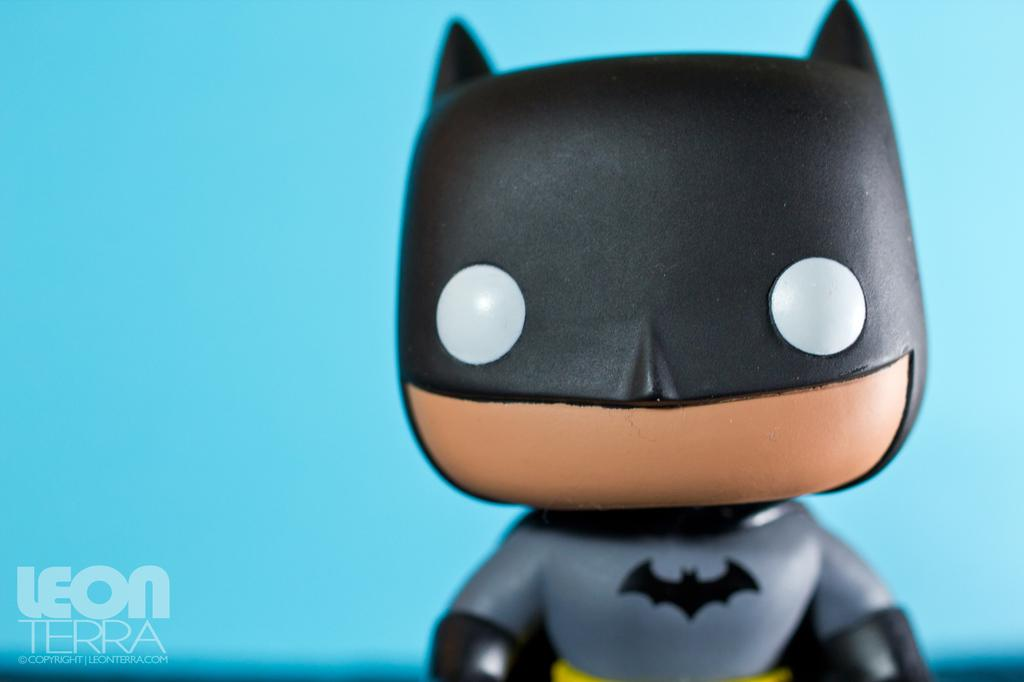What object can be seen in the image? There is a toy in the image. Where is the text located in the image? The text is in the bottom left of the image. What color is the background of the image? The background of the image is blue. What flavor of worm is depicted in the image? There is no worm present in the image, and therefore no flavor can be determined. 